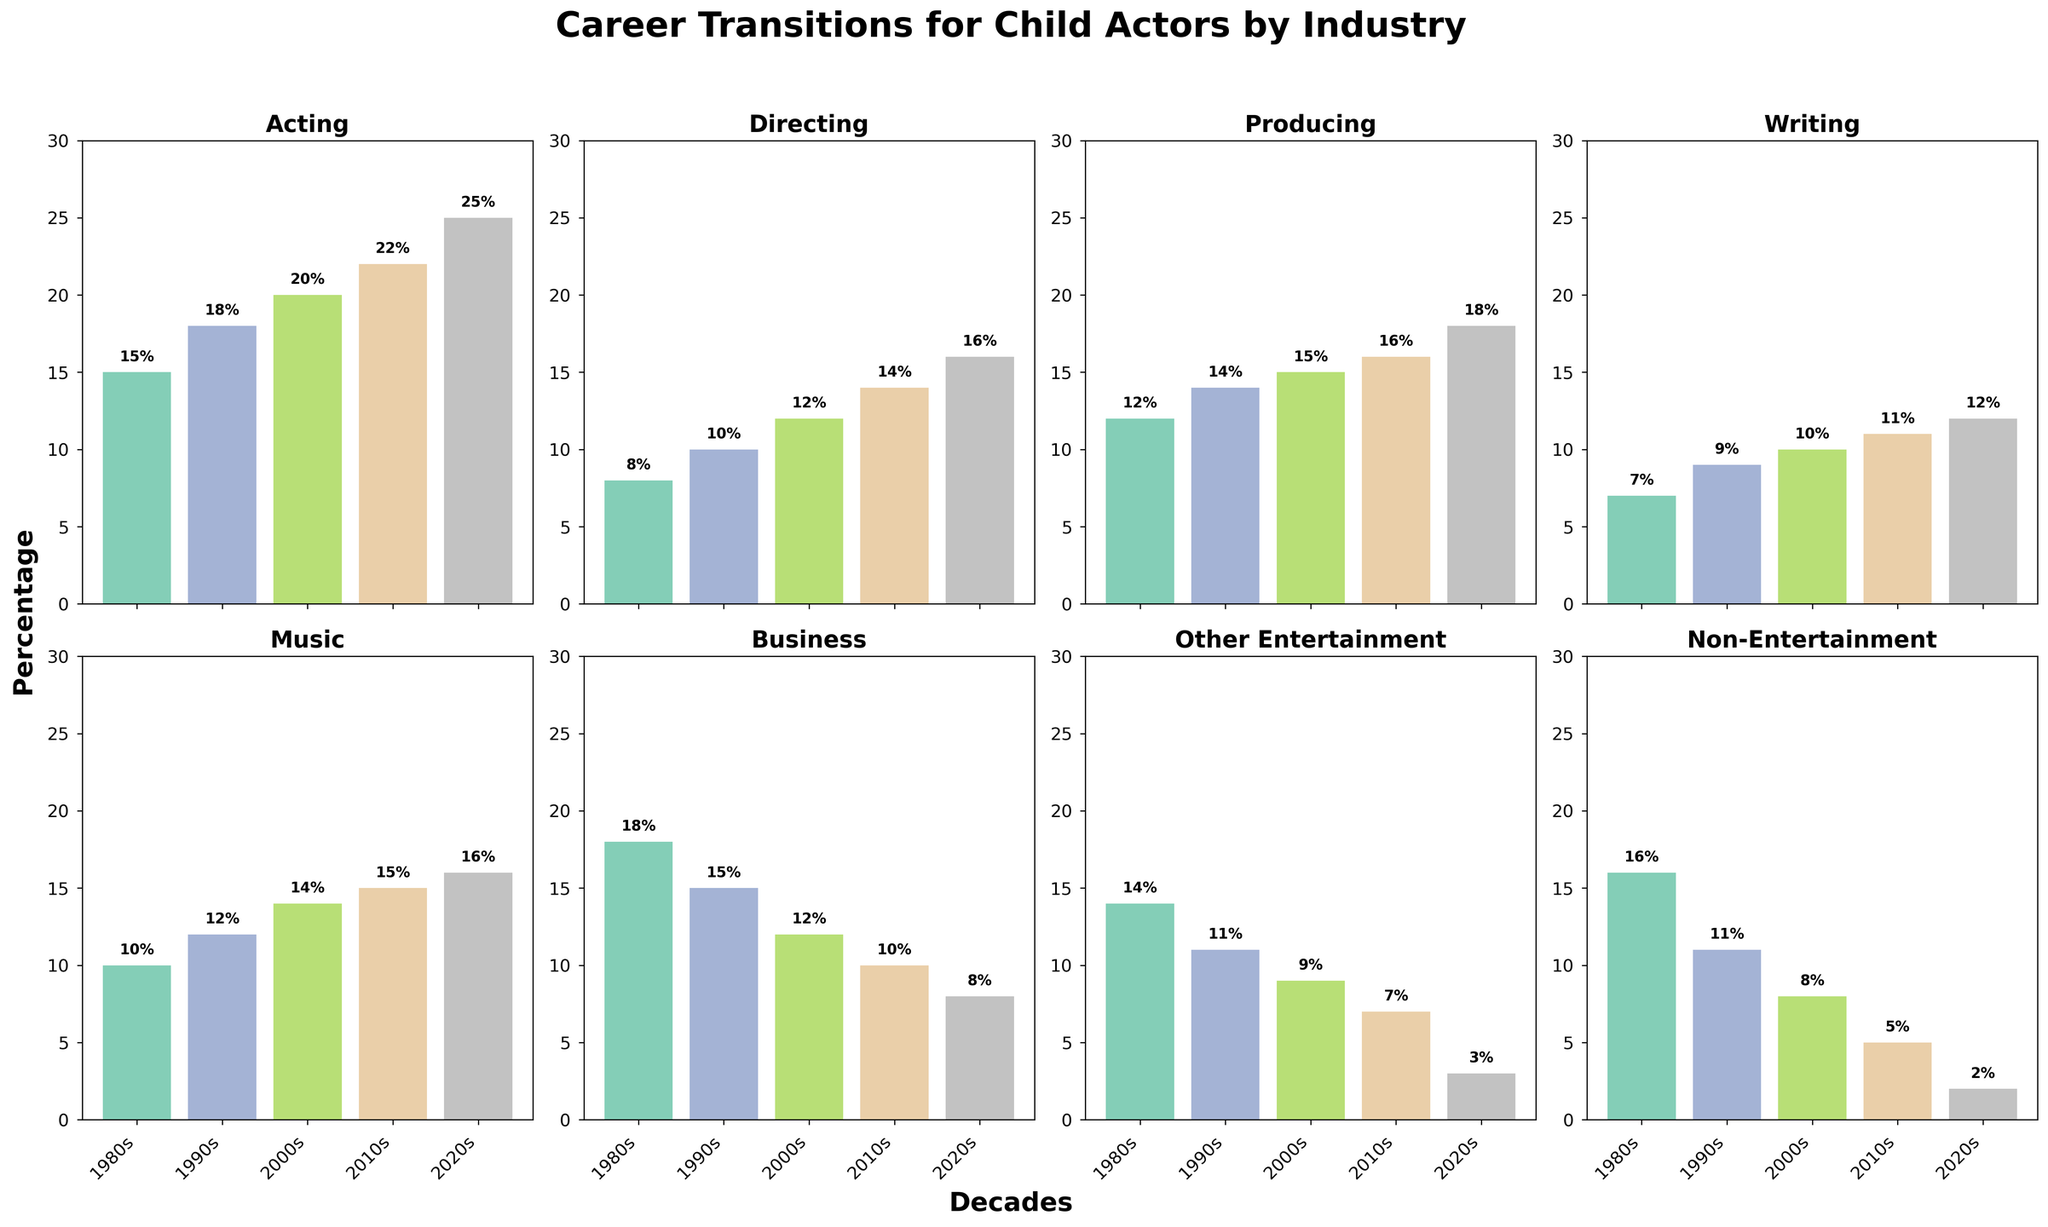What's the trend in the percentage of child actors transitioning into directing from the 1980s to the 2020s? The trend shows an increase over the decades. In the 1980s, it was 8%, then it increased steadily to 10% in the 1990s, 12% in the 2000s, 14% in the 2010s, and finally 16% in the 2020s.
Answer: It shows a steady increase Which industry had the highest percentage of successful career transitions for child actors in the 2020s? In the 2020s, music had the highest percentage of successful career transitions for child actors with 16%. This is evident since the bar for Music is the tallest among all the industries for the 2020s.
Answer: Music How does the percentage of child actors entering non-entertainment industries compare between the 1980s and the 2020s? The percentage of child actors transitioning into non-entertainment industries has decreased over time, from 16% in the 1980s to 2% in the 2020s. This is seen by comparing the height of the bars for Non-Entertainment in the two decades.
Answer: It decreased from 16% to 2% What is the average percentage of child actors transitioning into acting over the decades? The percentages for acting over the decades are 15%, 18%, 20%, 22%, and 25%. Summing these up gives 100%. Dividing by the 5 decades, the average is 20%.
Answer: 20% Which industry had the least fluctuation in career transition percentages over the decades? Business shows the least fluctuation in percentages; it starts at 18% in the 1980s and drops slightly to 8% in the 2020s with relatively smooth transitions. This is compared to other industries with larger variations.
Answer: Business By how many percentage points did the number of child actors transitioning into producing increase from the 1980s to the 2020s? The percentage increased from 12% in the 1980s to 18% in the 2020s, so the difference is 18% - 12% = 6 percentage points.
Answer: 6 Compare the percentage of child actors transitioning into Music and Writing in the 2000s. Which had a higher percentage, and by how much? In the 2000s, Music had a percentage of 14% while Writing had a percentage of 10%. The difference is 14% - 10% = 4%.
Answer: Music by 4% Did the industry with the highest percentage of career transitions change over the decades? If so, how? Yes, the industry with the highest percentage changed. In the 1980s, it was Business at 18%, in the 1990s and 2000s it was Acting at 18% and 20% respectively, while in the 2010s and 2020s it was Music at 15% and 16% respectively.
Answer: It changed from Business to Acting to Music What's the percentage increase in child actors transitioning into Writing from the 1980s to the 2020s? The percentage for Writing increased from 7% in the 1980s to 12% in the 2020s. The percentage increase is calculated as ((12 - 7) / 7) * 100% = 71.43%.
Answer: 71.43% What is the total percentage of child actors transitioning into 'Other Entertainment' across all decades combined? Adding the percentages for 'Other Entertainment' across all the decades: 14% (1980s) + 11% (1990s) + 9% (2000s) + 7% (2010s) + 3% (2020s) = 44%.
Answer: 44% 